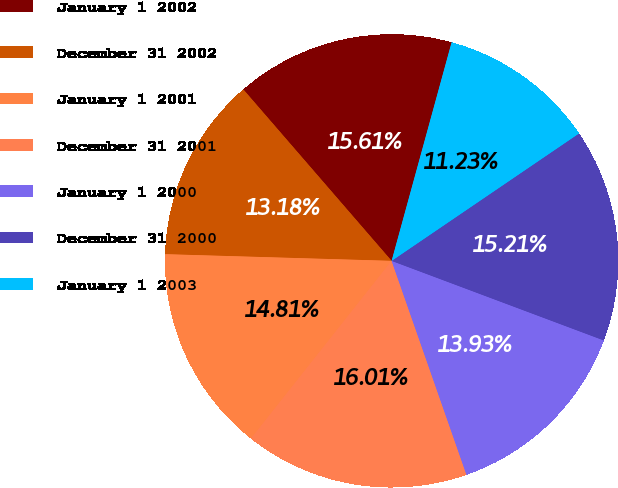Convert chart to OTSL. <chart><loc_0><loc_0><loc_500><loc_500><pie_chart><fcel>January 1 2002<fcel>December 31 2002<fcel>January 1 2001<fcel>December 31 2001<fcel>January 1 2000<fcel>December 31 2000<fcel>January 1 2003<nl><fcel>15.61%<fcel>13.18%<fcel>14.81%<fcel>16.01%<fcel>13.93%<fcel>15.21%<fcel>11.23%<nl></chart> 